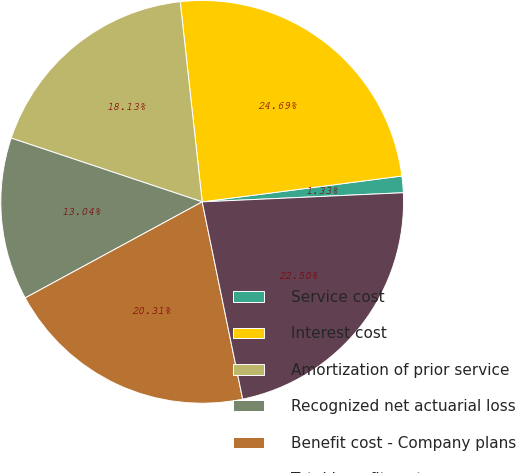<chart> <loc_0><loc_0><loc_500><loc_500><pie_chart><fcel>Service cost<fcel>Interest cost<fcel>Amortization of prior service<fcel>Recognized net actuarial loss<fcel>Benefit cost - Company plans<fcel>Total benefit cost<nl><fcel>1.33%<fcel>24.69%<fcel>18.13%<fcel>13.04%<fcel>20.31%<fcel>22.5%<nl></chart> 